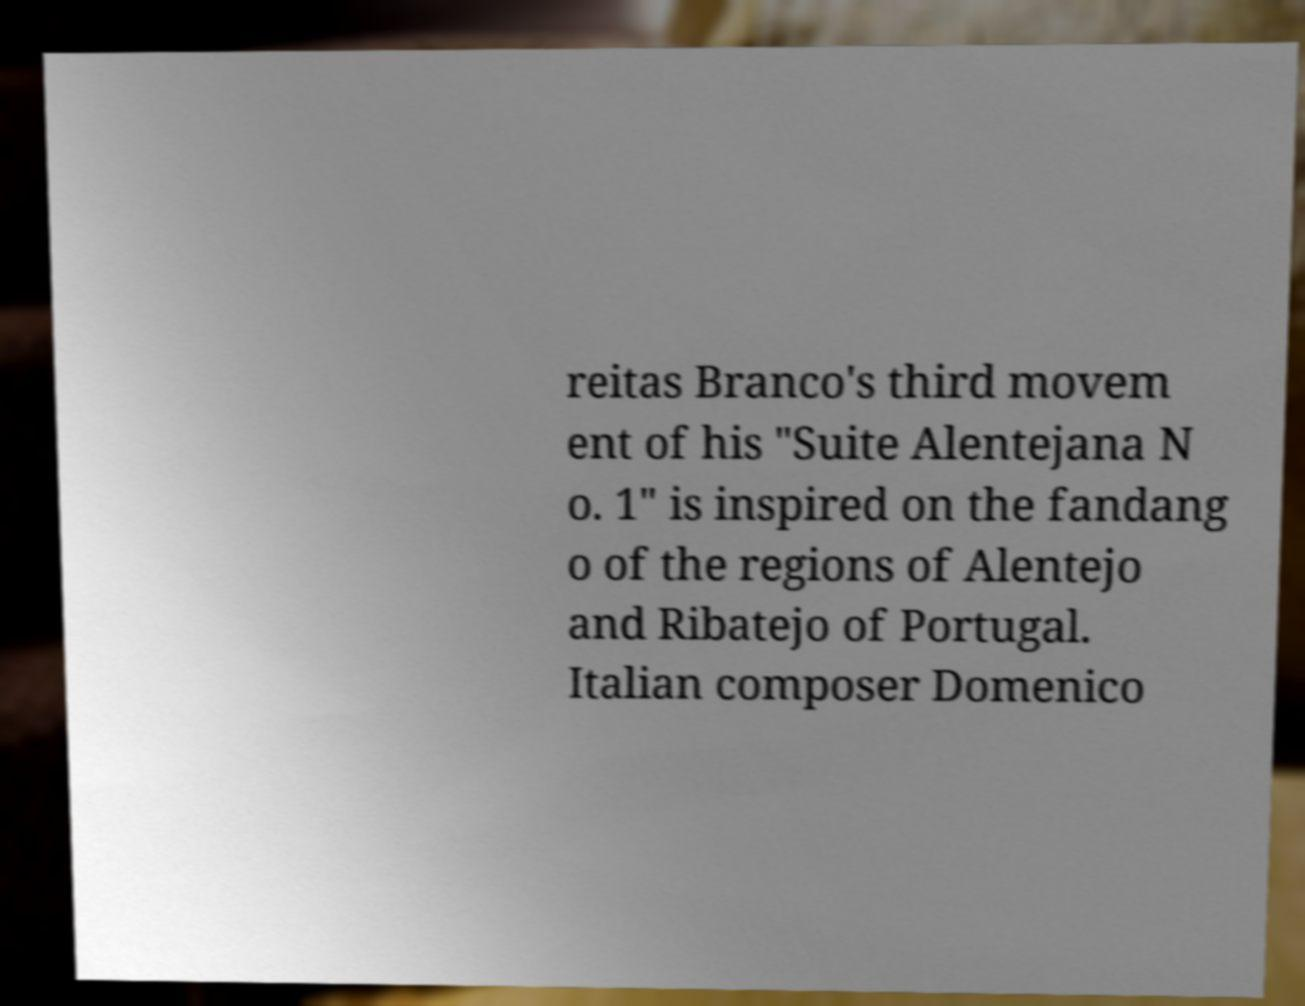Please read and relay the text visible in this image. What does it say? reitas Branco's third movem ent of his "Suite Alentejana N o. 1" is inspired on the fandang o of the regions of Alentejo and Ribatejo of Portugal. Italian composer Domenico 